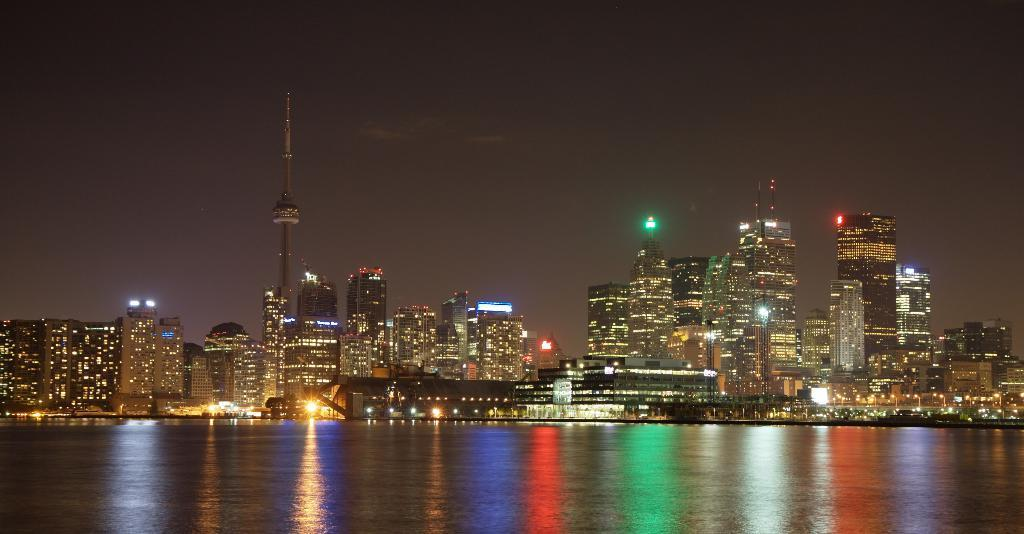What type of structures can be seen in the image? There are buildings in the image. What natural element is visible in the image? There is water visible in the image. What feature can be observed on the buildings? There are lights on the buildings. What tall structure is present in the image? There is a tower in the image. What can be seen in the background of the image? The sky is visible in the background of the image. What brand of toothpaste is advertised on the tower in the image? There is no toothpaste or advertisement present on the tower in the image. What type of show is taking place in the water in the image? There is no show or performance happening in the water in the image. 